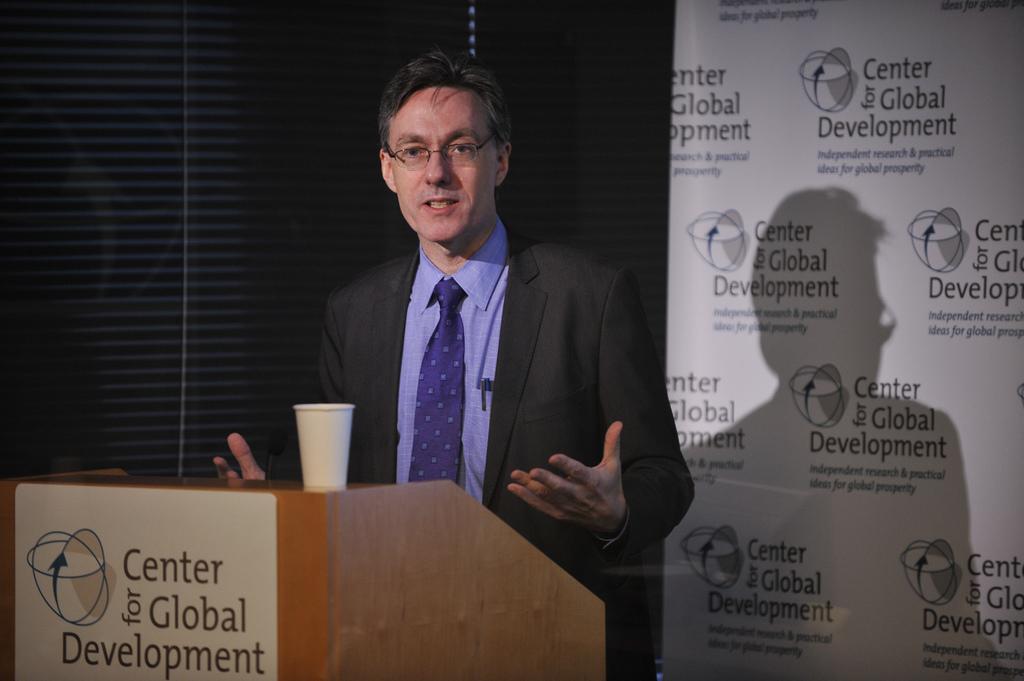Describe this image in one or two sentences. In this image there is a person wearing a blazer, tie and spectacles. He is standing. Before him there is a podium having a cup. Right side there is a banner having some text. Background there is a wall. 